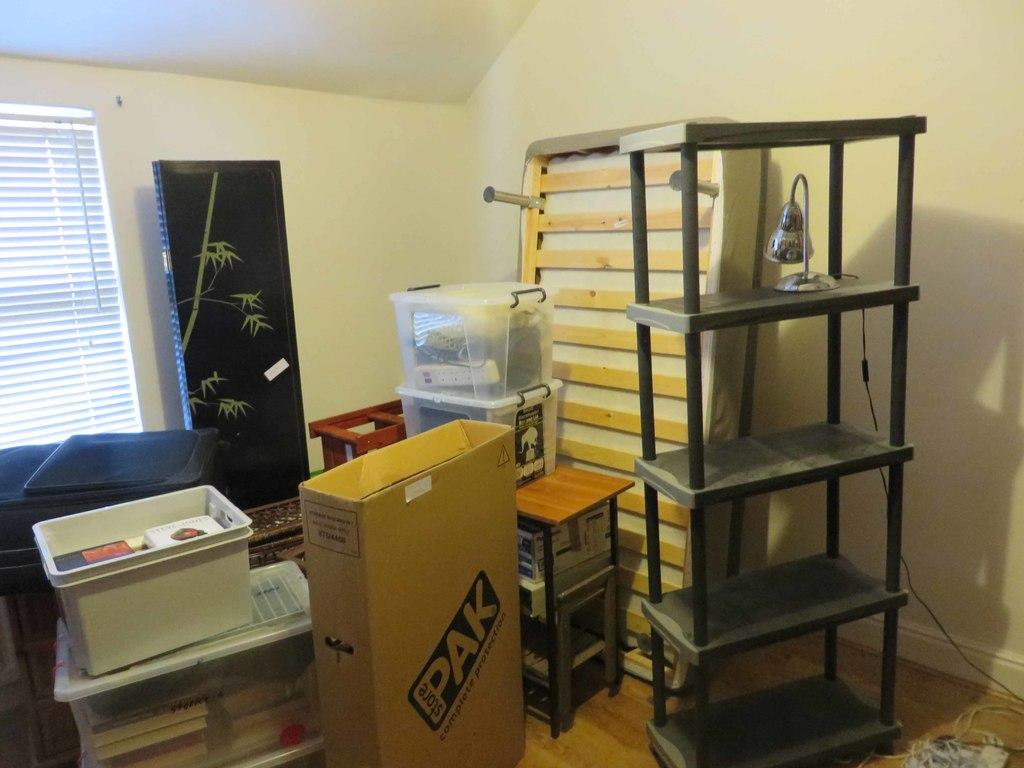<image>
Create a compact narrative representing the image presented. A box is in a room with other stuff that reads StorePak. 